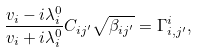Convert formula to latex. <formula><loc_0><loc_0><loc_500><loc_500>\frac { v _ { i } - i \lambda _ { i } ^ { 0 } } { v _ { i } + i \lambda _ { i } ^ { 0 } } C _ { i j ^ { \prime } } \sqrt { \beta _ { i j ^ { \prime } } } = \Gamma _ { i , j ^ { \prime } } ^ { i } ,</formula> 